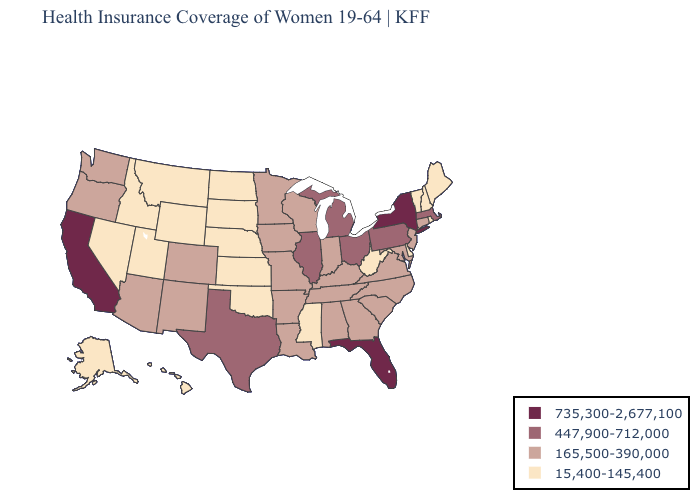Does the map have missing data?
Give a very brief answer. No. Does Missouri have the same value as Washington?
Short answer required. Yes. Name the states that have a value in the range 15,400-145,400?
Be succinct. Alaska, Delaware, Hawaii, Idaho, Kansas, Maine, Mississippi, Montana, Nebraska, Nevada, New Hampshire, North Dakota, Oklahoma, Rhode Island, South Dakota, Utah, Vermont, West Virginia, Wyoming. Name the states that have a value in the range 447,900-712,000?
Concise answer only. Illinois, Massachusetts, Michigan, Ohio, Pennsylvania, Texas. Which states have the lowest value in the USA?
Concise answer only. Alaska, Delaware, Hawaii, Idaho, Kansas, Maine, Mississippi, Montana, Nebraska, Nevada, New Hampshire, North Dakota, Oklahoma, Rhode Island, South Dakota, Utah, Vermont, West Virginia, Wyoming. What is the value of Tennessee?
Quick response, please. 165,500-390,000. Does Kansas have a lower value than Massachusetts?
Keep it brief. Yes. What is the highest value in the South ?
Give a very brief answer. 735,300-2,677,100. What is the value of West Virginia?
Short answer required. 15,400-145,400. Name the states that have a value in the range 15,400-145,400?
Quick response, please. Alaska, Delaware, Hawaii, Idaho, Kansas, Maine, Mississippi, Montana, Nebraska, Nevada, New Hampshire, North Dakota, Oklahoma, Rhode Island, South Dakota, Utah, Vermont, West Virginia, Wyoming. What is the highest value in the USA?
Quick response, please. 735,300-2,677,100. Does Kansas have the lowest value in the MidWest?
Answer briefly. Yes. Among the states that border Rhode Island , which have the highest value?
Keep it brief. Massachusetts. Which states have the lowest value in the USA?
Concise answer only. Alaska, Delaware, Hawaii, Idaho, Kansas, Maine, Mississippi, Montana, Nebraska, Nevada, New Hampshire, North Dakota, Oklahoma, Rhode Island, South Dakota, Utah, Vermont, West Virginia, Wyoming. What is the value of Indiana?
Short answer required. 165,500-390,000. 